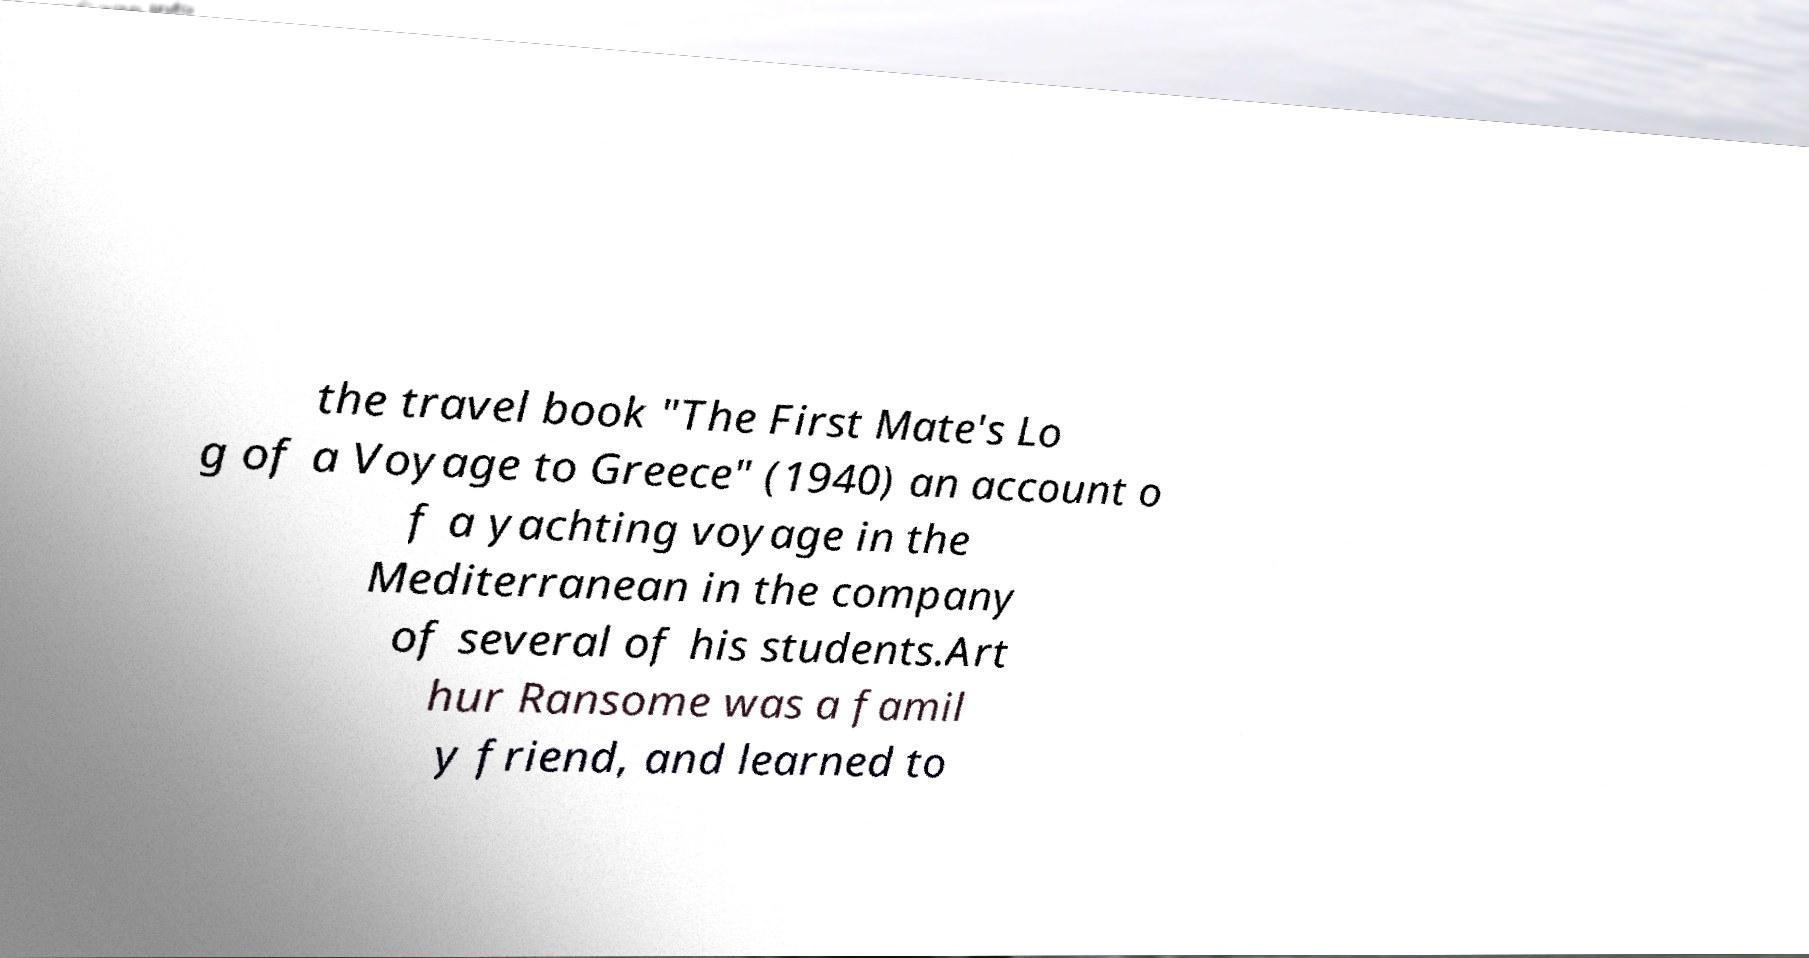Could you assist in decoding the text presented in this image and type it out clearly? the travel book "The First Mate's Lo g of a Voyage to Greece" (1940) an account o f a yachting voyage in the Mediterranean in the company of several of his students.Art hur Ransome was a famil y friend, and learned to 